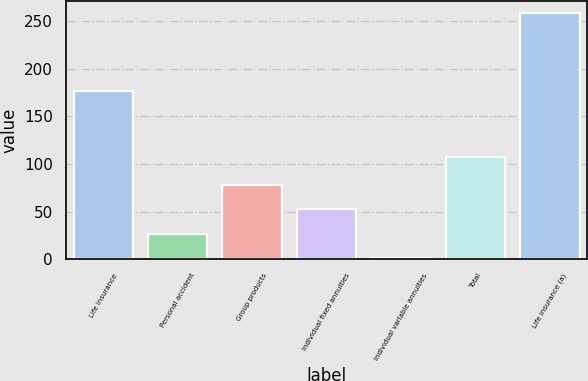<chart> <loc_0><loc_0><loc_500><loc_500><bar_chart><fcel>Life insurance<fcel>Personal accident<fcel>Group products<fcel>Individual fixed annuities<fcel>Individual variable annuities<fcel>Total<fcel>Life insurance (a)<nl><fcel>177<fcel>26.7<fcel>78.1<fcel>52.4<fcel>1<fcel>107<fcel>258<nl></chart> 